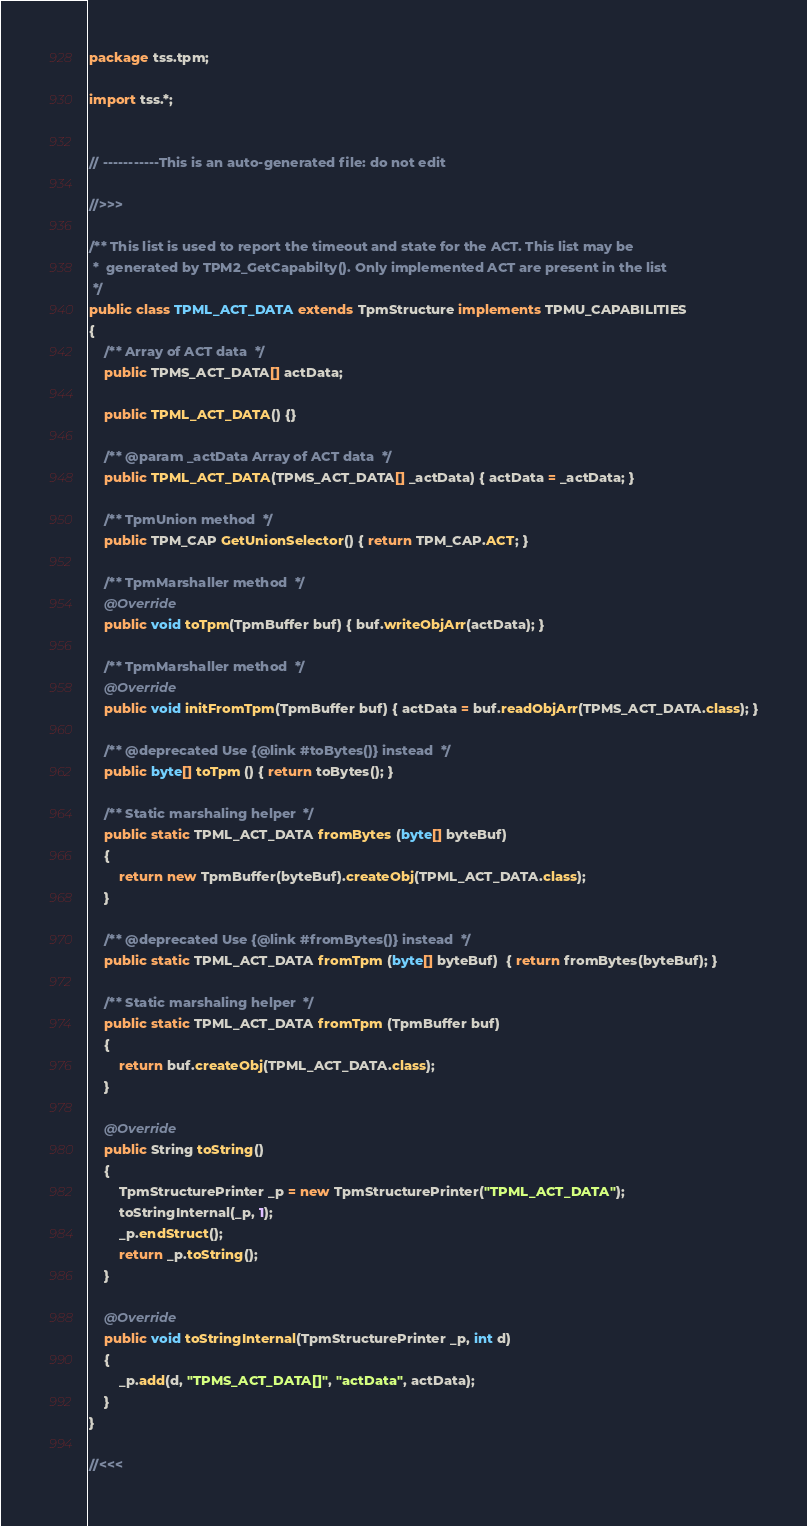<code> <loc_0><loc_0><loc_500><loc_500><_Java_>package tss.tpm;

import tss.*;


// -----------This is an auto-generated file: do not edit

//>>>

/** This list is used to report the timeout and state for the ACT. This list may be
 *  generated by TPM2_GetCapabilty(). Only implemented ACT are present in the list
 */
public class TPML_ACT_DATA extends TpmStructure implements TPMU_CAPABILITIES
{
    /** Array of ACT data  */
    public TPMS_ACT_DATA[] actData;

    public TPML_ACT_DATA() {}

    /** @param _actData Array of ACT data  */
    public TPML_ACT_DATA(TPMS_ACT_DATA[] _actData) { actData = _actData; }

    /** TpmUnion method  */
    public TPM_CAP GetUnionSelector() { return TPM_CAP.ACT; }

    /** TpmMarshaller method  */
    @Override
    public void toTpm(TpmBuffer buf) { buf.writeObjArr(actData); }

    /** TpmMarshaller method  */
    @Override
    public void initFromTpm(TpmBuffer buf) { actData = buf.readObjArr(TPMS_ACT_DATA.class); }

    /** @deprecated Use {@link #toBytes()} instead  */
    public byte[] toTpm () { return toBytes(); }

    /** Static marshaling helper  */
    public static TPML_ACT_DATA fromBytes (byte[] byteBuf) 
    {
        return new TpmBuffer(byteBuf).createObj(TPML_ACT_DATA.class);
    }

    /** @deprecated Use {@link #fromBytes()} instead  */
    public static TPML_ACT_DATA fromTpm (byte[] byteBuf)  { return fromBytes(byteBuf); }

    /** Static marshaling helper  */
    public static TPML_ACT_DATA fromTpm (TpmBuffer buf) 
    {
        return buf.createObj(TPML_ACT_DATA.class);
    }

    @Override
    public String toString()
    {
        TpmStructurePrinter _p = new TpmStructurePrinter("TPML_ACT_DATA");
        toStringInternal(_p, 1);
        _p.endStruct();
        return _p.toString();
    }

    @Override
    public void toStringInternal(TpmStructurePrinter _p, int d)
    {
        _p.add(d, "TPMS_ACT_DATA[]", "actData", actData);
    }
}

//<<<
</code> 